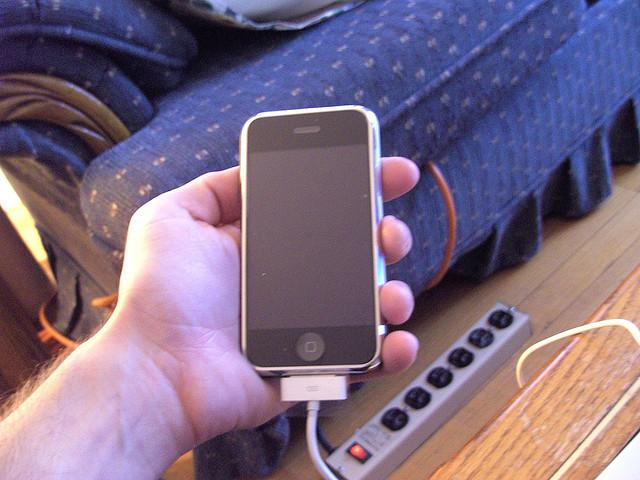What is the item on the floor called?

Choices:
A) staple gun
B) machete
C) power strip
D) bolt cutter power strip 